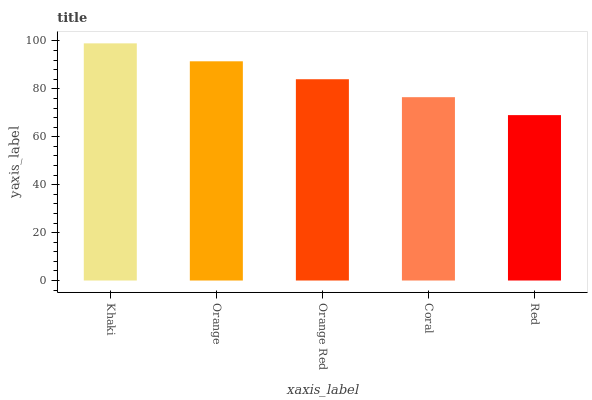Is Red the minimum?
Answer yes or no. Yes. Is Khaki the maximum?
Answer yes or no. Yes. Is Orange the minimum?
Answer yes or no. No. Is Orange the maximum?
Answer yes or no. No. Is Khaki greater than Orange?
Answer yes or no. Yes. Is Orange less than Khaki?
Answer yes or no. Yes. Is Orange greater than Khaki?
Answer yes or no. No. Is Khaki less than Orange?
Answer yes or no. No. Is Orange Red the high median?
Answer yes or no. Yes. Is Orange Red the low median?
Answer yes or no. Yes. Is Coral the high median?
Answer yes or no. No. Is Khaki the low median?
Answer yes or no. No. 